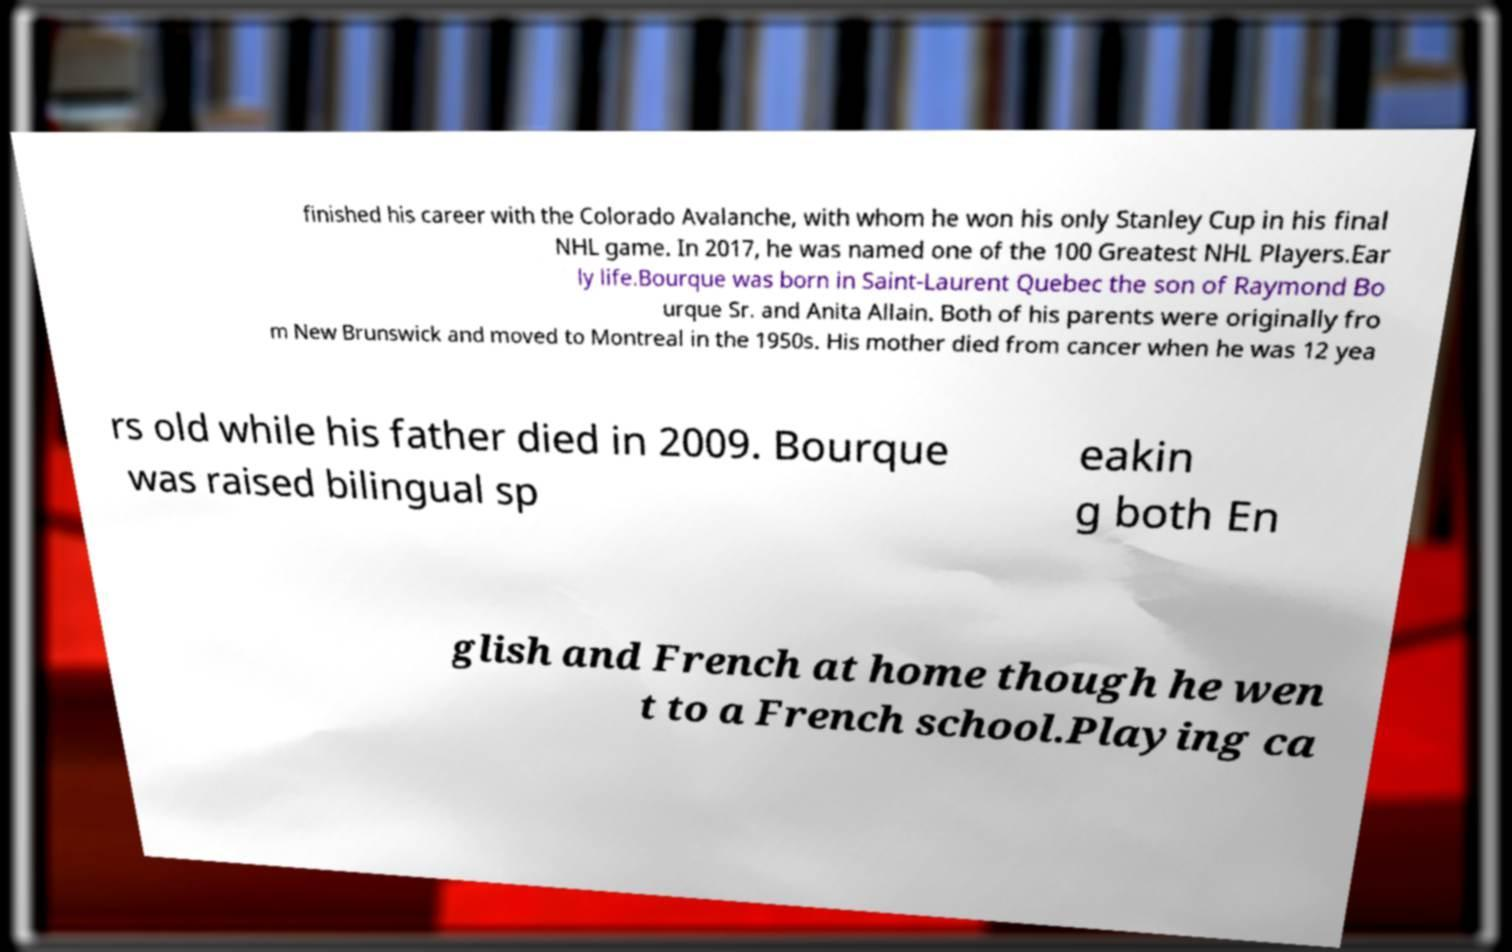For documentation purposes, I need the text within this image transcribed. Could you provide that? finished his career with the Colorado Avalanche, with whom he won his only Stanley Cup in his final NHL game. In 2017, he was named one of the 100 Greatest NHL Players.Ear ly life.Bourque was born in Saint-Laurent Quebec the son of Raymond Bo urque Sr. and Anita Allain. Both of his parents were originally fro m New Brunswick and moved to Montreal in the 1950s. His mother died from cancer when he was 12 yea rs old while his father died in 2009. Bourque was raised bilingual sp eakin g both En glish and French at home though he wen t to a French school.Playing ca 